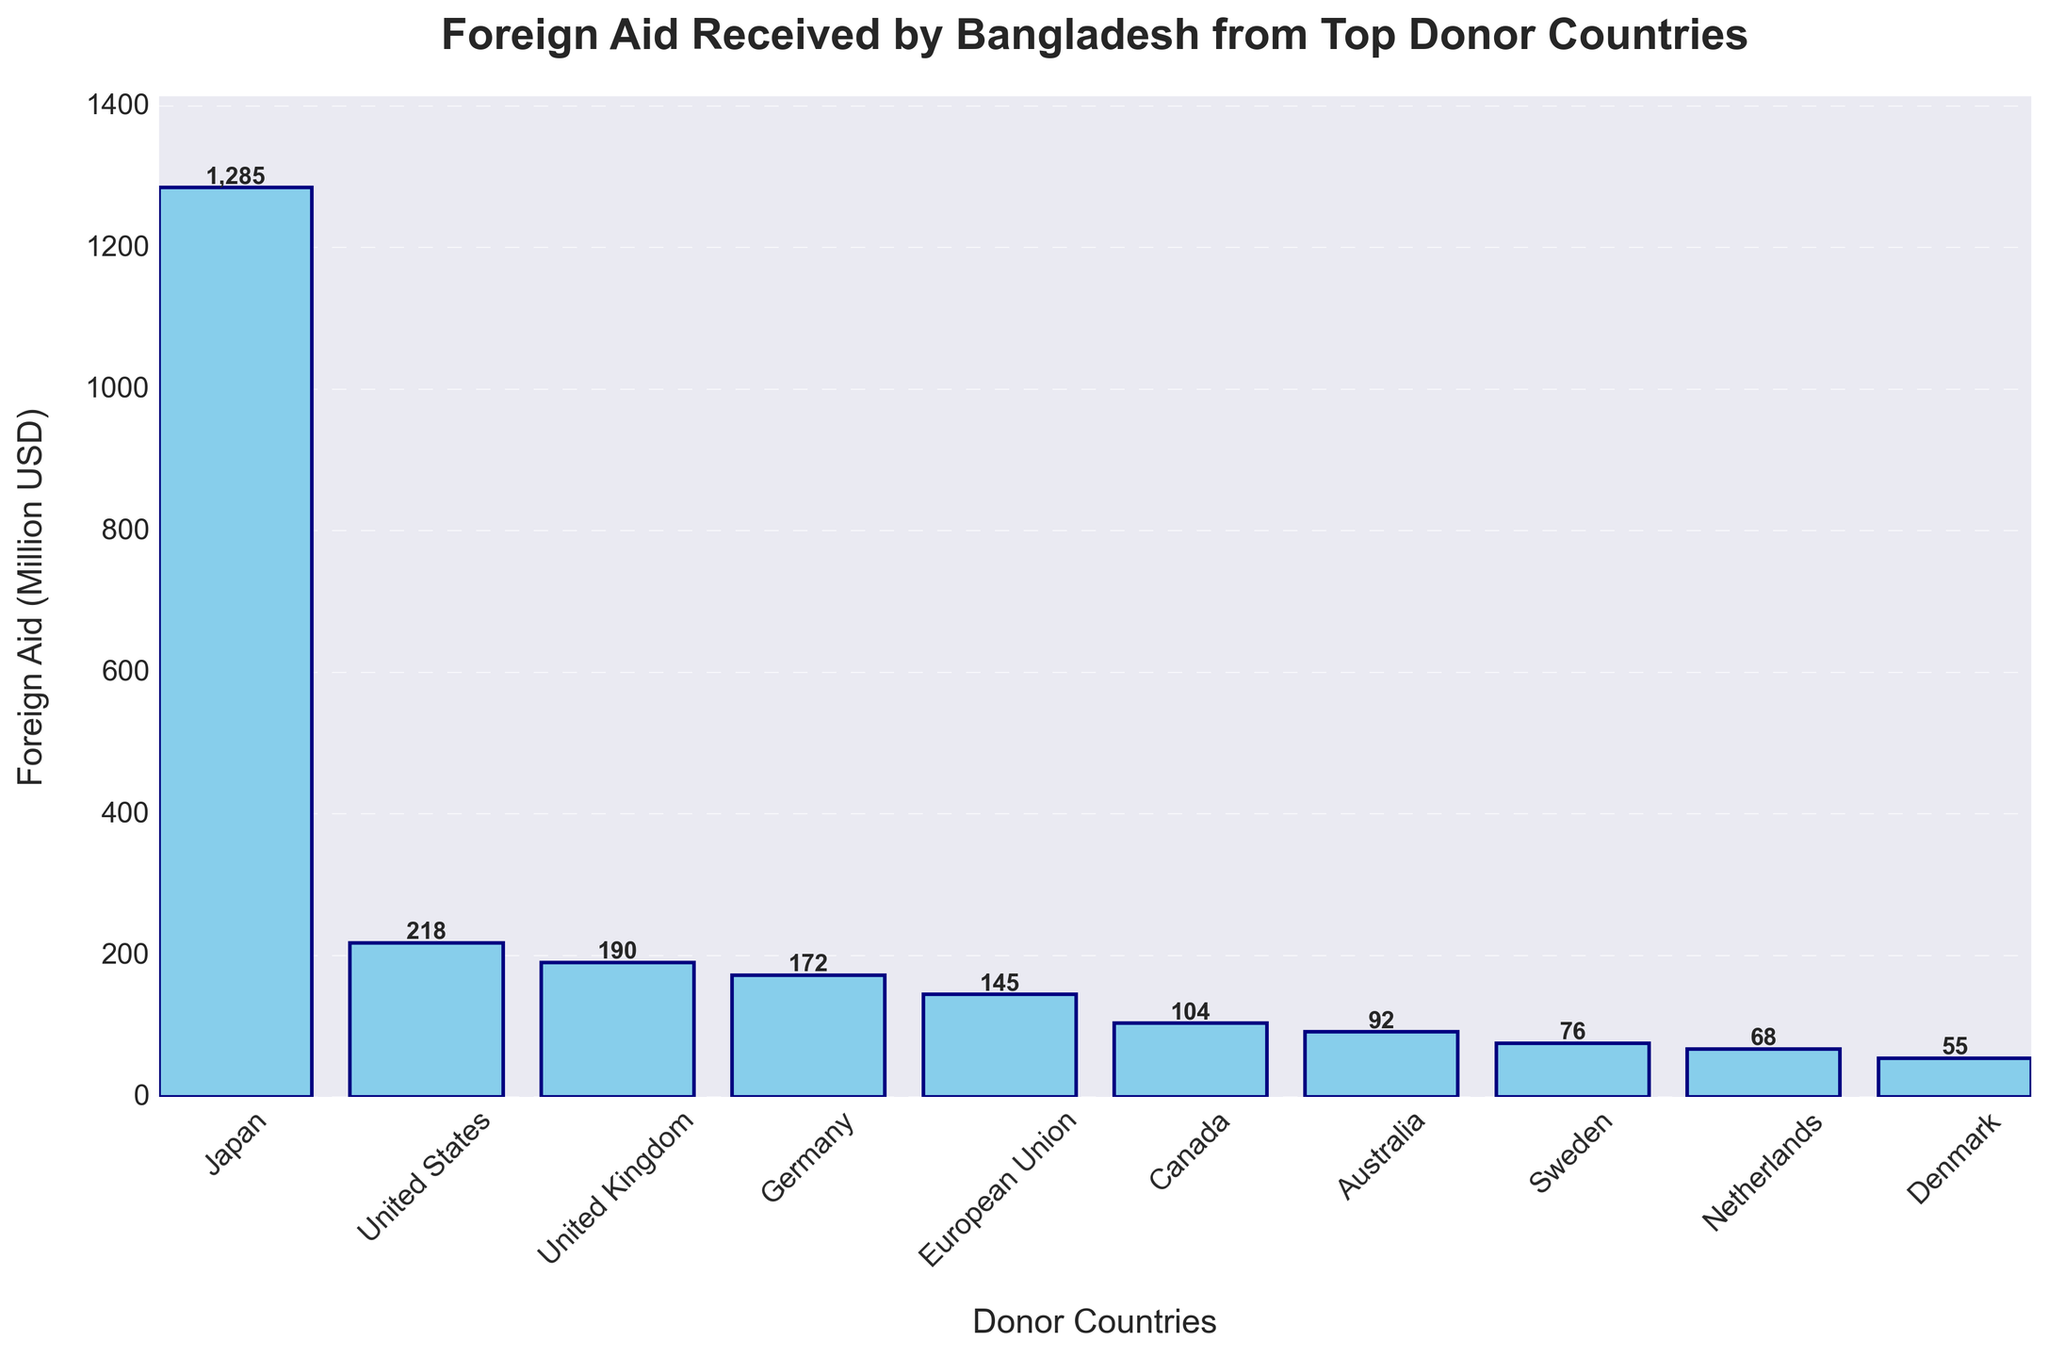Which country provided the highest amount of foreign aid to Bangladesh? By observing the height of the bars, Japan's bar is the tallest, indicating it provided the highest amount of foreign aid. The label on the Japan bar shows 1285 million USD.
Answer: Japan Which donor country ranks fifth in terms of foreign aid provided? By arranging the heights of the bars from highest to lowest, the fifth bar from the top is for the European Union. The label on the European Union bar shows 145 million USD.
Answer: European Union What is the total foreign aid received from the top three donor countries combined? The top three donor countries based on the bar heights are Japan, United States, and United Kingdom. Summing their aid amounts: 1285 (Japan) + 218 (United States) + 190 (United Kingdom) = 1693 million USD.
Answer: 1693 How much more aid did Japan provide compared to the United States? Subtract the aid amount provided by the United States from the aid amount provided by Japan: 1285 (Japan) - 218 (United States) = 1067 million USD.
Answer: 1067 Which country provided the least amount of foreign aid to Bangladesh? By observing the shortest bar, Denmark provided the least amount of foreign aid. The label on the Denmark bar shows 55 million USD.
Answer: Denmark What is the average foreign aid received from all the donor countries listed? Sum all the aid amounts and divide by the number of countries: (1285 + 218 + 190 + 172 + 145 + 104 + 92 + 76 + 68 + 55) / 10 = 2405 / 10 = 240.5 million USD.
Answer: 240.5 How many countries provided more than 100 million USD in foreign aid? By identifying bars with aid amounts greater than 100 million USD, there are six countries: Japan, United States, United Kingdom, Germany, European Union, and Canada.
Answer: 6 Which country provided just slightly more aid than Sweden? By observing the bar heights and labels around Sweden's bar (76 million USD), the Netherlands provided 68 million USD, which is slightly less, while Canada provided 104 million USD, which is more. Thus, Canada is the correct answer.
Answer: Canada What is the range of the foreign aid amounts received? The range is found by subtracting the smallest amount (Denmark, 55 million USD) from the largest amount (Japan, 1285 million USD): 1285 - 55 = 1230 million USD.
Answer: 1230 What is the difference in foreign aid between the United Kingdom and Germany? Subtract the aid amount of Germany from the aid amount of the United Kingdom: 190 (United Kingdom) - 172 (Germany) = 18 million USD.
Answer: 18 